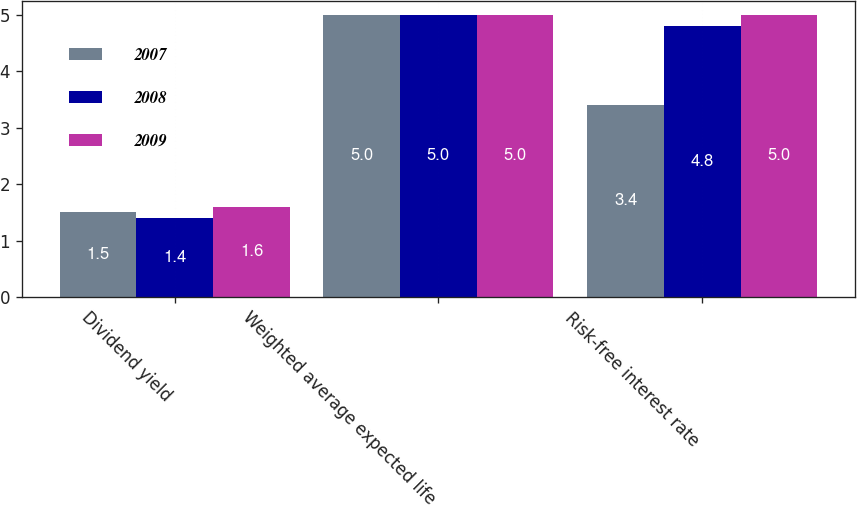<chart> <loc_0><loc_0><loc_500><loc_500><stacked_bar_chart><ecel><fcel>Dividend yield<fcel>Weighted average expected life<fcel>Risk-free interest rate<nl><fcel>2007<fcel>1.5<fcel>5<fcel>3.4<nl><fcel>2008<fcel>1.4<fcel>5<fcel>4.8<nl><fcel>2009<fcel>1.6<fcel>5<fcel>5<nl></chart> 